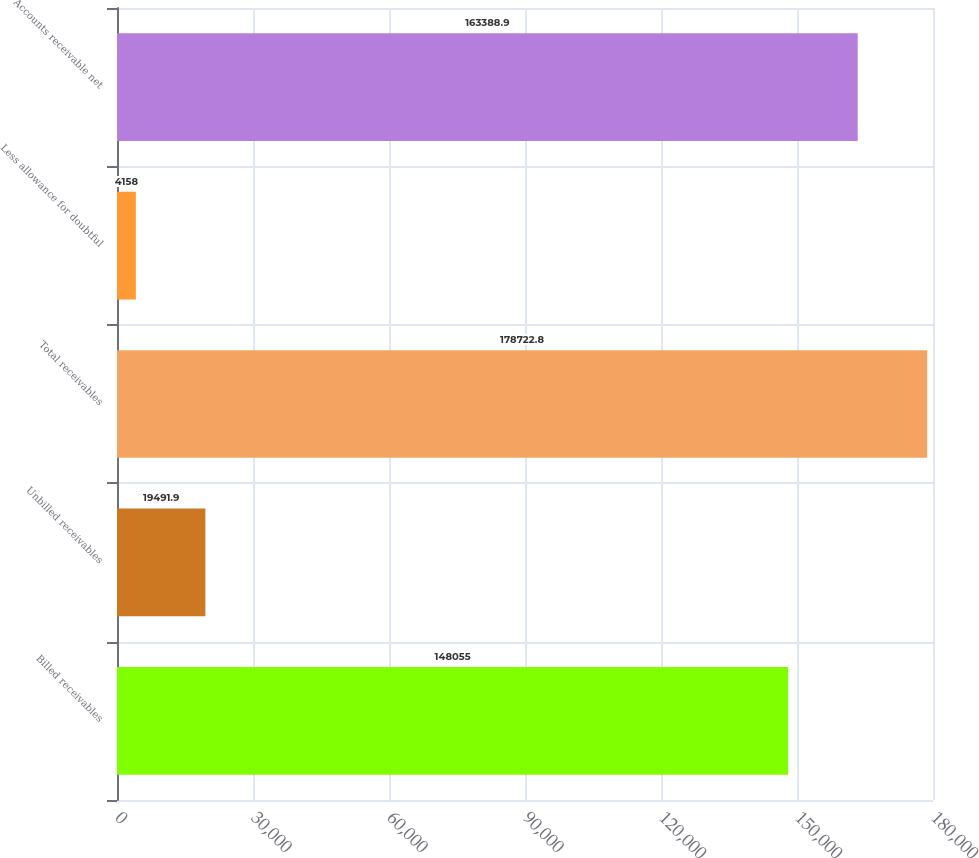Convert chart to OTSL. <chart><loc_0><loc_0><loc_500><loc_500><bar_chart><fcel>Billed receivables<fcel>Unbilled receivables<fcel>Total receivables<fcel>Less allowance for doubtful<fcel>Accounts receivable net<nl><fcel>148055<fcel>19491.9<fcel>178723<fcel>4158<fcel>163389<nl></chart> 